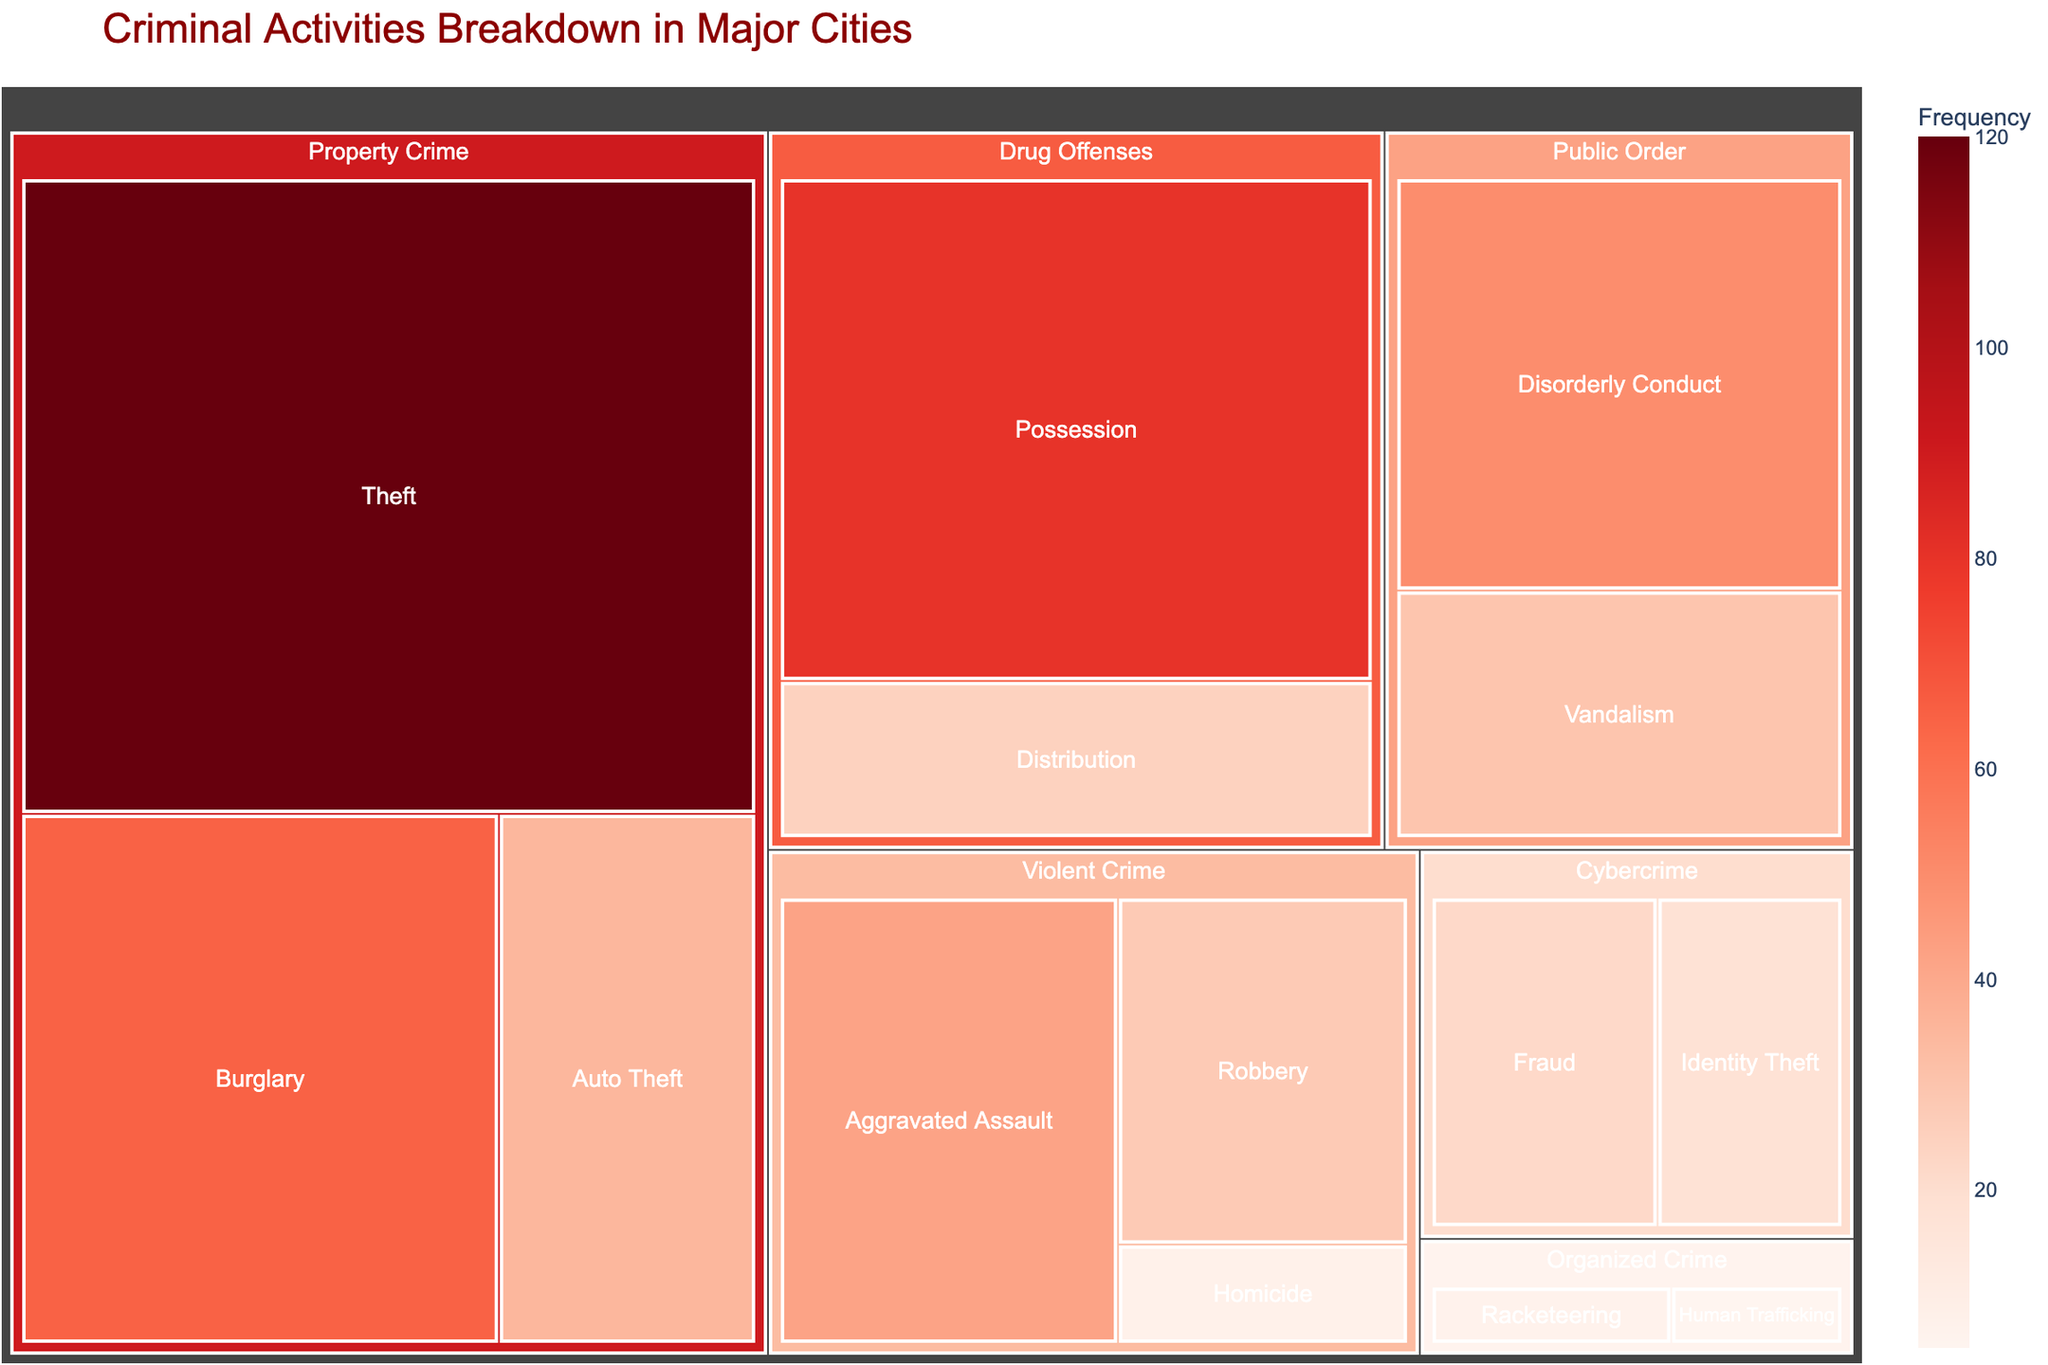What's the most frequent type of crime in major cities? The most frequent type of crime can be identified by looking for the category with the largest value. In this case, "Property Crime" has the highest value.
Answer: Property Crime Which subcategory within Violent Crime has the highest frequency? To determine this, inspect the subcategories under "Violent Crime" and compare their values. "Aggravated Assault" has the highest value among the subcategories listed.
Answer: Aggravated Assault What is the combined frequency of all Drug Offenses? Sum the values of the subcategories under "Drug Offenses". The values are 80 and 25 for "Possession" and "Distribution" respectively. So, 80 + 25 = 105.
Answer: 105 How does the frequency of Theft compare to that of Auto Theft? To compare the frequencies, look at their values and compute the difference. Theft has a frequency of 120, while Auto Theft has a frequency of 35. The difference is 120 - 35 = 85.
Answer: Theft is 85 more frequent than Auto Theft What's the least frequent subcategory within Public Order crimes? Inspect the subcategories under "Public Order". "Vandalism" has a value of 30, whereas "Disorderly Conduct" has 50. Therefore, "Vandalism" is less frequent.
Answer: Vandalism Which category has the smallest total frequency and what is it? Compare the sum of the values for each category. "Organized Crime" has values 7 and 5 for its subcategories, respectively. The total is 7 + 5 = 12, which is the smallest among all categories.
Answer: Organized Crime, 12 What's the frequency difference between Violent Crime and Public Order crimes? Sum the values of the subcategories under each category. Violent Crime has 42 + 28 + 8 = 78. Public Order has 50 + 30 = 80. The difference is 78 - 80 = -2. Public Order crimes are more frequent.
Answer: Public Order is 2 more frequent Which has a higher frequency: Cybercrime or Drug Offenses? Sum the values for each category. Cybercrime has 18 + 22 = 40. Drug Offenses have 80 + 25 = 105. Drug Offenses have a higher frequency.
Answer: Drug Offenses What percentage of all crimes do Property Crimes constitute? First, find the total frequency of all crimes. Sum all values: 42 + 28 + 8 + 65 + 120 + 35 + 80 + 25 + 50 + 30 + 18 + 22 + 7 + 5 = 535. Property Crimes total to 65 + 120 + 35 = 220. The percentage is (220/535) * 100 ≈ 41.12%.
Answer: Approximately 41.12% 